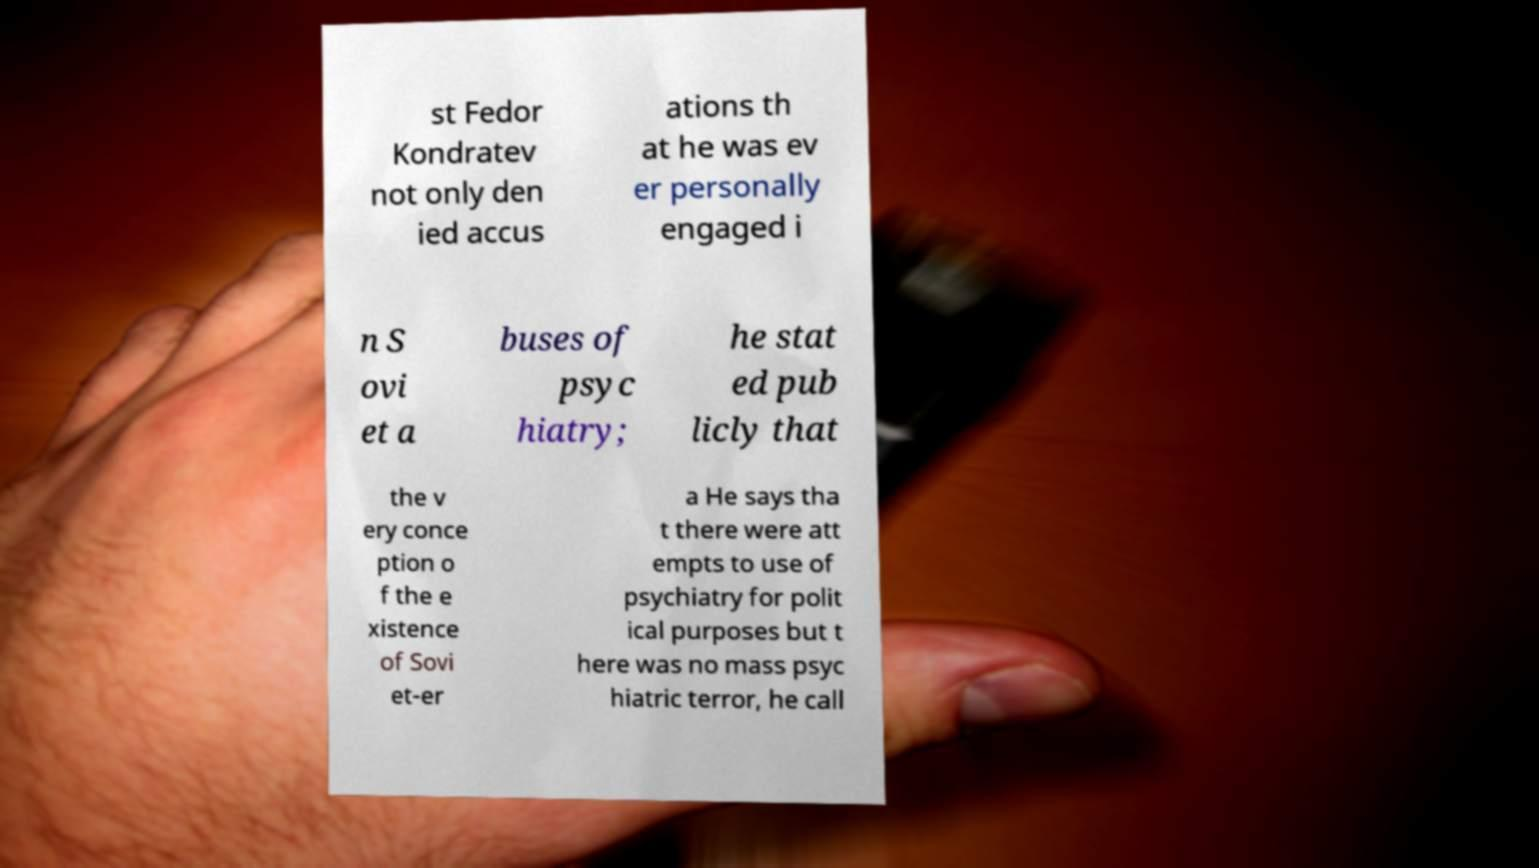I need the written content from this picture converted into text. Can you do that? st Fedor Kondratev not only den ied accus ations th at he was ev er personally engaged i n S ovi et a buses of psyc hiatry; he stat ed pub licly that the v ery conce ption o f the e xistence of Sovi et-er a He says tha t there were att empts to use of psychiatry for polit ical purposes but t here was no mass psyc hiatric terror, he call 